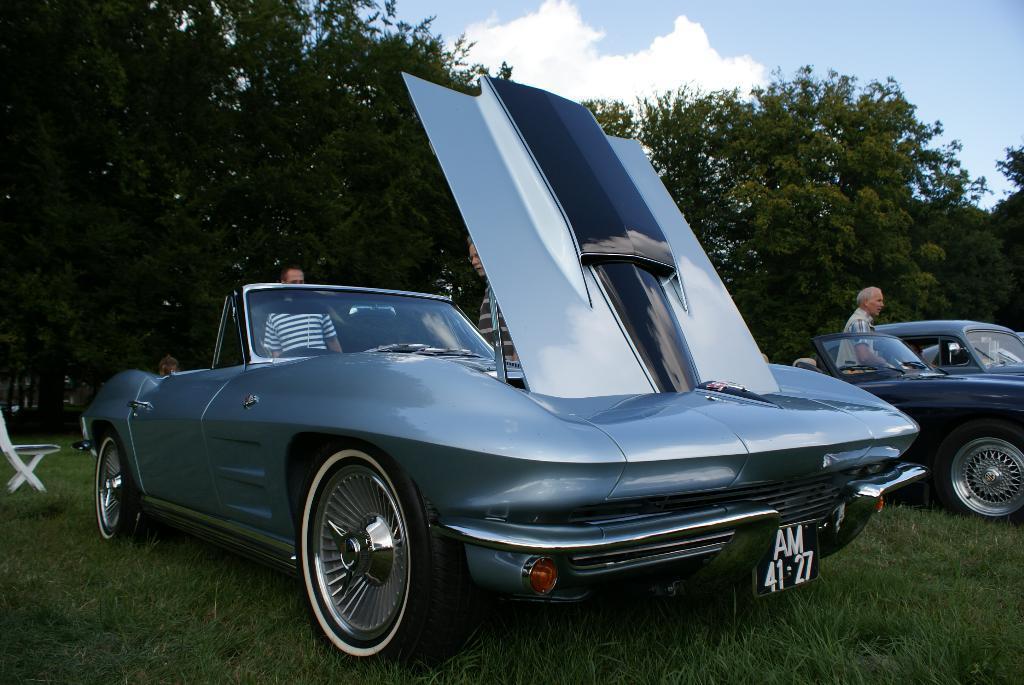Could you give a brief overview of what you see in this image? In this image, I can see three persons standing and there are two cars on the grass. On the left side of the image, I can see a chair. In the background, there are trees and the sky. 